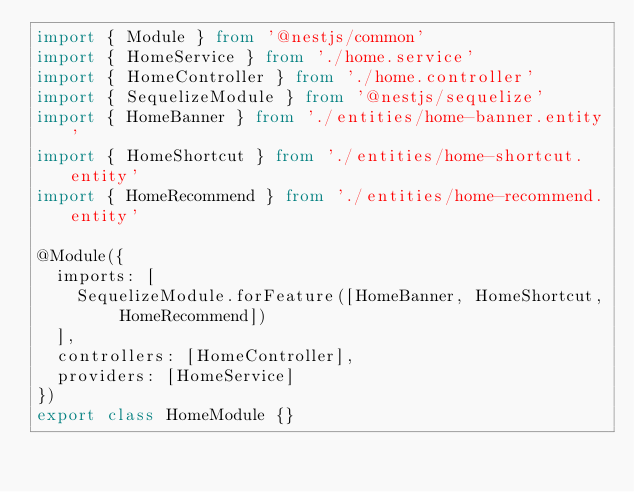<code> <loc_0><loc_0><loc_500><loc_500><_TypeScript_>import { Module } from '@nestjs/common'
import { HomeService } from './home.service'
import { HomeController } from './home.controller'
import { SequelizeModule } from '@nestjs/sequelize'
import { HomeBanner } from './entities/home-banner.entity'
import { HomeShortcut } from './entities/home-shortcut.entity'
import { HomeRecommend } from './entities/home-recommend.entity'

@Module({
  imports: [
    SequelizeModule.forFeature([HomeBanner, HomeShortcut, HomeRecommend])
  ],
  controllers: [HomeController],
  providers: [HomeService]
})
export class HomeModule {}
</code> 